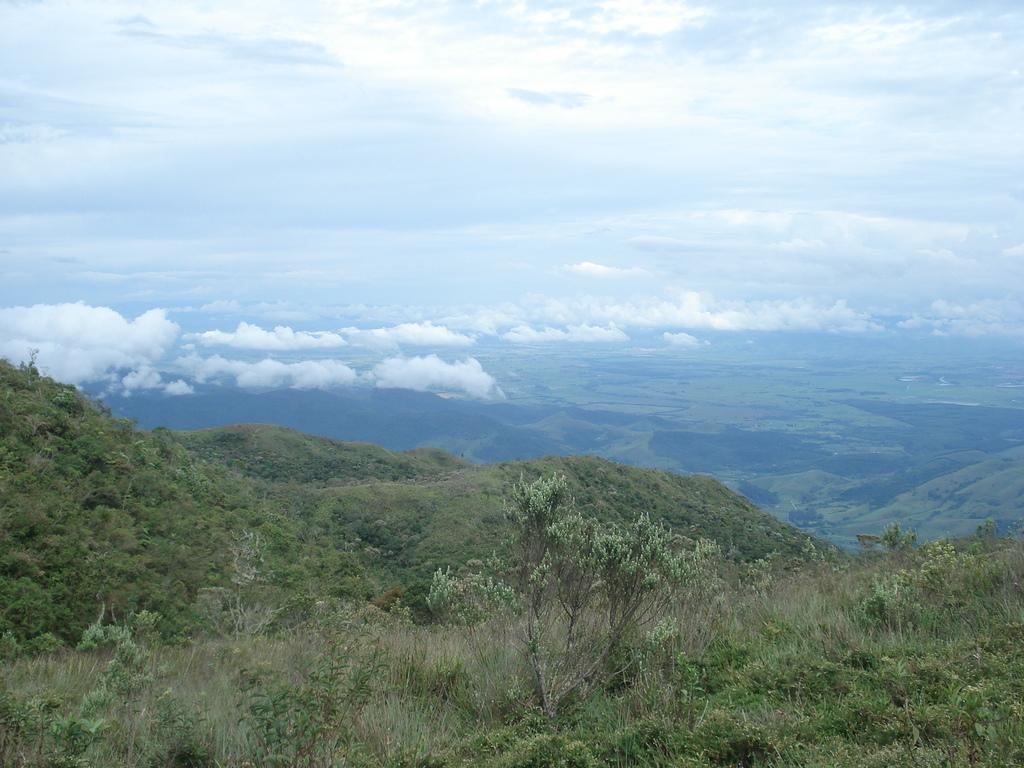Could you give a brief overview of what you see in this image? This image is clicked on the hills. There are plants and grass on the hills. In the background there are hills. At the top there is the sky. The sky is cloudy. 